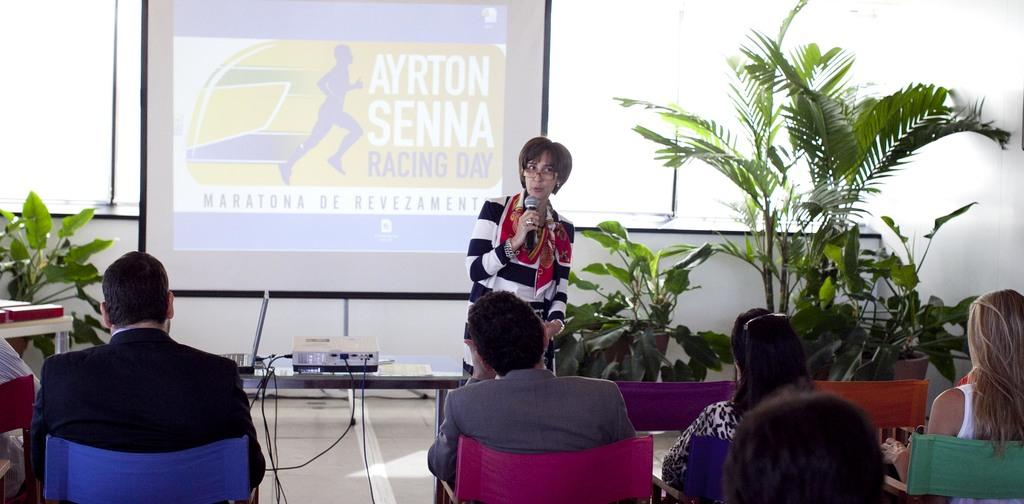What are the people in the image doing? The people in the image are sitting on chairs. What is the woman in the image doing? The woman is standing and holding a microphone in her hand. What object is present on the table in the image? There is a projector on the table in the image. What might be used for presentations or displaying visuals in the image? The projector on the table might be used for presentations or displaying visuals. What type of machine can be seen operating on the woman's toes in the image? There is no machine operating on the woman's toes in the image; she is simply holding a microphone. 